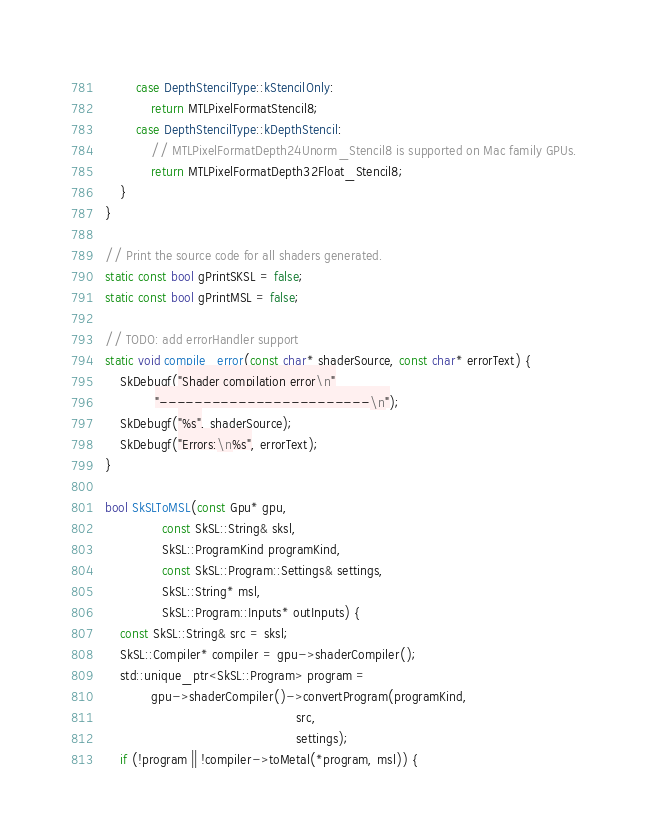<code> <loc_0><loc_0><loc_500><loc_500><_ObjectiveC_>        case DepthStencilType::kStencilOnly:
            return MTLPixelFormatStencil8;
        case DepthStencilType::kDepthStencil:
            // MTLPixelFormatDepth24Unorm_Stencil8 is supported on Mac family GPUs.
            return MTLPixelFormatDepth32Float_Stencil8;
    }
}

// Print the source code for all shaders generated.
static const bool gPrintSKSL = false;
static const bool gPrintMSL = false;

// TODO: add errorHandler support
static void compile_error(const char* shaderSource, const char* errorText) {
    SkDebugf("Shader compilation error\n"
             "------------------------\n");
    SkDebugf("%s", shaderSource);
    SkDebugf("Errors:\n%s", errorText);
}

bool SkSLToMSL(const Gpu* gpu,
               const SkSL::String& sksl,
               SkSL::ProgramKind programKind,
               const SkSL::Program::Settings& settings,
               SkSL::String* msl,
               SkSL::Program::Inputs* outInputs) {
    const SkSL::String& src = sksl;
    SkSL::Compiler* compiler = gpu->shaderCompiler();
    std::unique_ptr<SkSL::Program> program =
            gpu->shaderCompiler()->convertProgram(programKind,
                                                  src,
                                                  settings);
    if (!program || !compiler->toMetal(*program, msl)) {</code> 